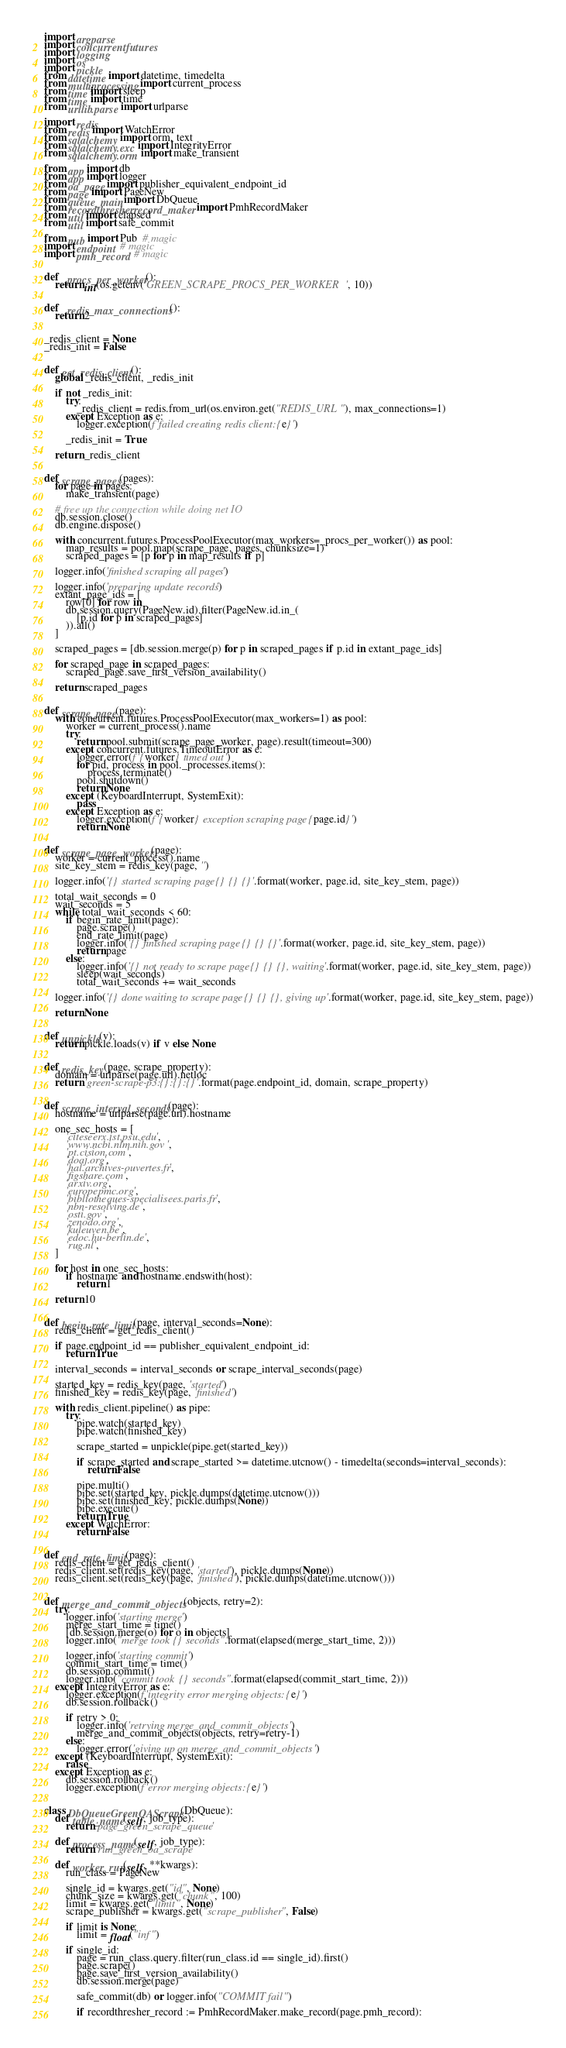<code> <loc_0><loc_0><loc_500><loc_500><_Python_>import argparse
import concurrent.futures
import logging
import os
import pickle
from datetime import datetime, timedelta
from multiprocessing import current_process
from time import sleep
from time import time
from urllib.parse import urlparse

import redis
from redis import WatchError
from sqlalchemy import orm, text
from sqlalchemy.exc import IntegrityError
from sqlalchemy.orm import make_transient

from app import db
from app import logger
from oa_page import publisher_equivalent_endpoint_id
from page import PageNew
from queue_main import DbQueue
from recordthresher.record_maker import PmhRecordMaker
from util import elapsed
from util import safe_commit

from pub import Pub  # magic
import endpoint  # magic
import pmh_record  # magic


def _procs_per_worker():
    return int(os.getenv('GREEN_SCRAPE_PROCS_PER_WORKER', 10))


def _redis_max_connections():
    return 2


_redis_client = None
_redis_init = False


def get_redis_client():
    global _redis_client, _redis_init

    if not _redis_init:
        try:
            _redis_client = redis.from_url(os.environ.get("REDIS_URL"), max_connections=1)
        except Exception as e:
            logger.exception(f'failed creating redis client: {e}')

        _redis_init = True

    return _redis_client


def scrape_pages(pages):
    for page in pages:
        make_transient(page)

    # free up the connection while doing net IO
    db.session.close()
    db.engine.dispose()

    with concurrent.futures.ProcessPoolExecutor(max_workers=_procs_per_worker()) as pool:
        map_results = pool.map(scrape_page, pages, chunksize=1)
        scraped_pages = [p for p in map_results if p]

    logger.info('finished scraping all pages')

    logger.info('preparing update records')
    extant_page_ids = [
        row[0] for row in
        db.session.query(PageNew.id).filter(PageNew.id.in_(
            [p.id for p in scraped_pages]
        )).all()
    ]

    scraped_pages = [db.session.merge(p) for p in scraped_pages if p.id in extant_page_ids]

    for scraped_page in scraped_pages:
        scraped_page.save_first_version_availability()

    return scraped_pages


def scrape_page(page):
    with concurrent.futures.ProcessPoolExecutor(max_workers=1) as pool:
        worker = current_process().name
        try:
            return pool.submit(scrape_page_worker, page).result(timeout=300)
        except concurrent.futures.TimeoutError as e:
            logger.error(f'{worker} timed out')
            for pid, process in pool._processes.items():
                process.terminate()
            pool.shutdown()
            return None
        except (KeyboardInterrupt, SystemExit):
            pass
        except Exception as e:
            logger.exception(f'{worker} exception scraping page {page.id}')
            return None


def scrape_page_worker(page):
    worker = current_process().name
    site_key_stem = redis_key(page, '')

    logger.info('{} started scraping page {} {} {}'.format(worker, page.id, site_key_stem, page))

    total_wait_seconds = 0
    wait_seconds = 5
    while total_wait_seconds < 60:
        if begin_rate_limit(page):
            page.scrape()
            end_rate_limit(page)
            logger.info('{} finished scraping page {} {} {}'.format(worker, page.id, site_key_stem, page))
            return page
        else:
            logger.info('{} not ready to scrape page {} {} {}, waiting'.format(worker, page.id, site_key_stem, page))
            sleep(wait_seconds)
            total_wait_seconds += wait_seconds

    logger.info('{} done waiting to scrape page {} {} {}, giving up'.format(worker, page.id, site_key_stem, page))

    return None


def unpickle(v):
    return pickle.loads(v) if v else None


def redis_key(page, scrape_property):
    domain = urlparse(page.url).netloc
    return 'green-scrape-p3:{}:{}:{}'.format(page.endpoint_id, domain, scrape_property)


def scrape_interval_seconds(page):
    hostname = urlparse(page.url).hostname

    one_sec_hosts = [
        'citeseerx.ist.psu.edu',
        'www.ncbi.nlm.nih.gov',
        'pt.cision.com',
        'doaj.org',
        'hal.archives-ouvertes.fr',
        'figshare.com',
        'arxiv.org',
        'europepmc.org',
        'bibliotheques-specialisees.paris.fr',
        'nbn-resolving.de',
        'osti.gov',
        'zenodo.org',
        'kuleuven.be',
        'edoc.hu-berlin.de',
        'rug.nl',
    ]

    for host in one_sec_hosts:
        if hostname and hostname.endswith(host):
            return 1

    return 10


def begin_rate_limit(page, interval_seconds=None):
    redis_client = get_redis_client()

    if page.endpoint_id == publisher_equivalent_endpoint_id:
        return True

    interval_seconds = interval_seconds or scrape_interval_seconds(page)

    started_key = redis_key(page, 'started')
    finished_key = redis_key(page, 'finished')

    with redis_client.pipeline() as pipe:
        try:
            pipe.watch(started_key)
            pipe.watch(finished_key)

            scrape_started = unpickle(pipe.get(started_key))

            if scrape_started and scrape_started >= datetime.utcnow() - timedelta(seconds=interval_seconds):
                return False

            pipe.multi()
            pipe.set(started_key, pickle.dumps(datetime.utcnow()))
            pipe.set(finished_key, pickle.dumps(None))
            pipe.execute()
            return True
        except WatchError:
            return False


def end_rate_limit(page):
    redis_client = get_redis_client()
    redis_client.set(redis_key(page, 'started'), pickle.dumps(None))
    redis_client.set(redis_key(page, 'finished'), pickle.dumps(datetime.utcnow()))


def merge_and_commit_objects(objects, retry=2):
    try:
        logger.info('starting merge')
        merge_start_time = time()
        [db.session.merge(o) for o in objects]
        logger.info("merge took {} seconds".format(elapsed(merge_start_time, 2)))

        logger.info('starting commit')
        commit_start_time = time()
        db.session.commit()
        logger.info("commit took {} seconds".format(elapsed(commit_start_time, 2)))
    except IntegrityError as e:
        logger.exception(f'integrity error merging objects: {e}')
        db.session.rollback()

        if retry > 0:
            logger.info('retrying merge_and_commit_objects')
            merge_and_commit_objects(objects, retry=retry-1)
        else:
            logger.error('giving up on merge_and_commit_objects')
    except (KeyboardInterrupt, SystemExit):
        raise
    except Exception as e:
        db.session.rollback()
        logger.exception(f'error merging objects: {e}')


class DbQueueGreenOAScrape(DbQueue):
    def table_name(self, job_type):
        return 'page_green_scrape_queue'

    def process_name(self, job_type):
        return 'run_green_oa_scrape'

    def worker_run(self, **kwargs):
        run_class = PageNew

        single_id = kwargs.get("id", None)
        chunk_size = kwargs.get("chunk", 100)
        limit = kwargs.get("limit", None)
        scrape_publisher = kwargs.get("scrape_publisher", False)

        if limit is None:
            limit = float("inf")

        if single_id:
            page = run_class.query.filter(run_class.id == single_id).first()
            page.scrape()
            page.save_first_version_availability()
            db.session.merge(page)

            safe_commit(db) or logger.info("COMMIT fail")

            if recordthresher_record := PmhRecordMaker.make_record(page.pmh_record):</code> 